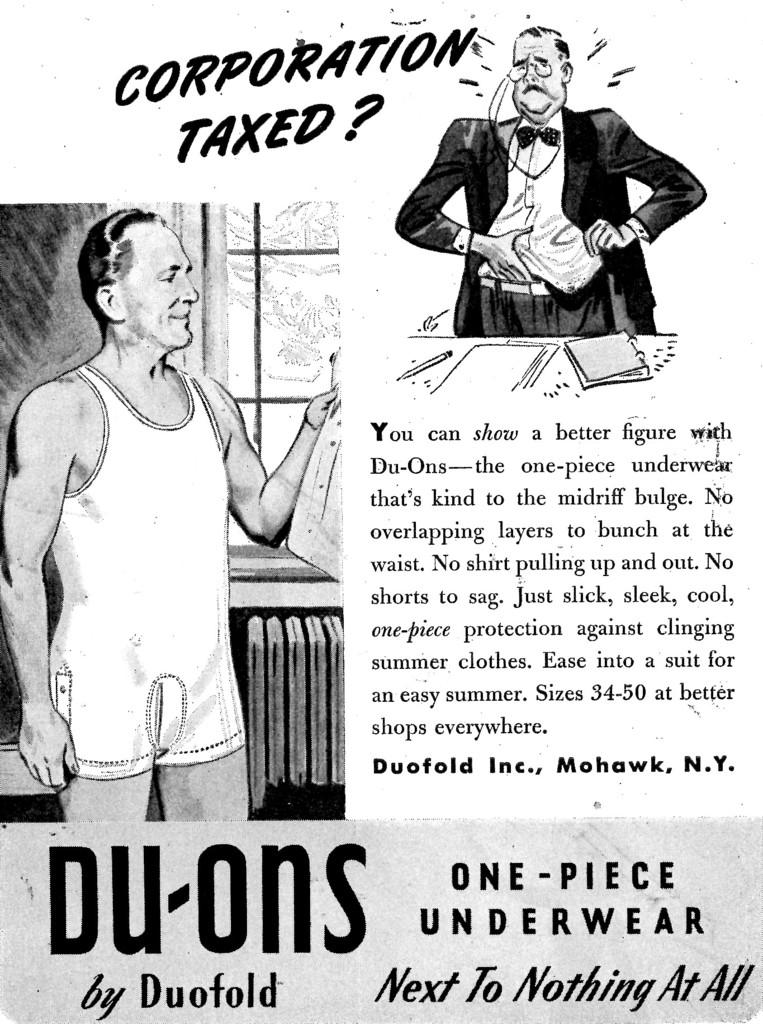What is featured in the picture? A: There is a poster in the picture. What can be found on the poster? The poster contains text and cartoon images of men. What type of slope is depicted in the image? There is no slope present in the image; it features a poster with text and cartoon images of men. What kind of wrench is being used by the men in the image? There are no men or wrenches present in the image; it only contains a poster with text and cartoon images of men. 